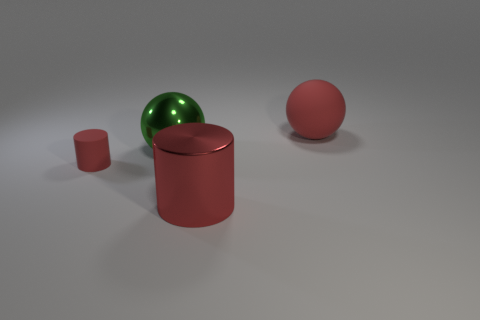Subtract all red spheres. How many spheres are left? 1 Add 3 big red balls. How many objects exist? 7 Subtract 2 spheres. How many spheres are left? 0 Subtract all green cylinders. Subtract all green cubes. How many cylinders are left? 2 Subtract all yellow blocks. How many cyan cylinders are left? 0 Subtract all tiny red rubber objects. Subtract all tiny purple matte cylinders. How many objects are left? 3 Add 4 tiny cylinders. How many tiny cylinders are left? 5 Add 4 blue matte blocks. How many blue matte blocks exist? 4 Subtract 0 gray spheres. How many objects are left? 4 